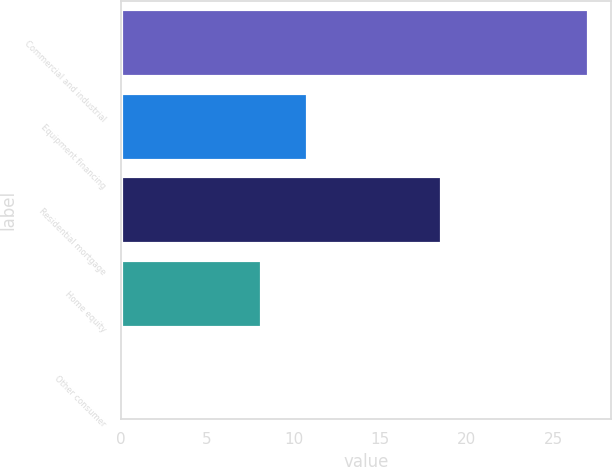Convert chart. <chart><loc_0><loc_0><loc_500><loc_500><bar_chart><fcel>Commercial and industrial<fcel>Equipment financing<fcel>Residential mortgage<fcel>Home equity<fcel>Other consumer<nl><fcel>27<fcel>10.8<fcel>18.5<fcel>8.1<fcel>0.2<nl></chart> 